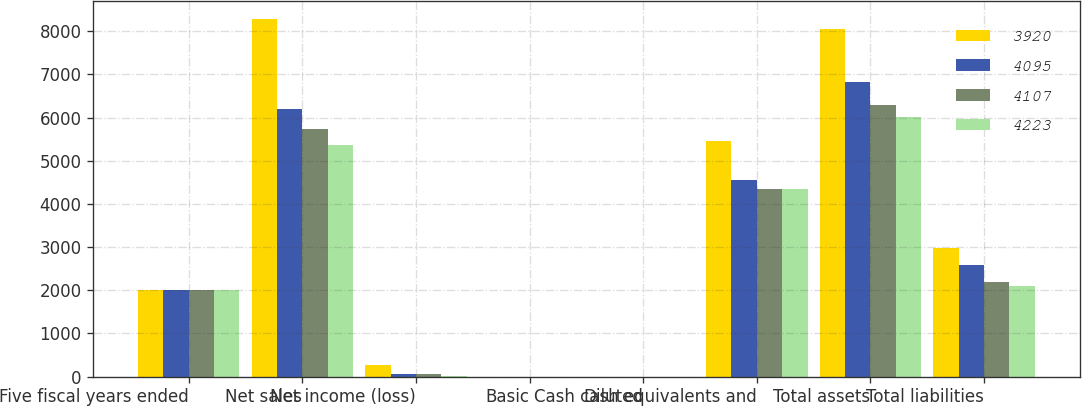<chart> <loc_0><loc_0><loc_500><loc_500><stacked_bar_chart><ecel><fcel>Five fiscal years ended<fcel>Net sales<fcel>Net income (loss)<fcel>Basic<fcel>Diluted<fcel>Cash cash equivalents and<fcel>Total assets<fcel>Total liabilities<nl><fcel>3920<fcel>2004<fcel>8279<fcel>276<fcel>0.74<fcel>0.71<fcel>5464<fcel>8050<fcel>2974<nl><fcel>4095<fcel>2003<fcel>6207<fcel>69<fcel>0.19<fcel>0.19<fcel>4566<fcel>6815<fcel>2592<nl><fcel>4107<fcel>2002<fcel>5742<fcel>65<fcel>0.18<fcel>0.18<fcel>4337<fcel>6298<fcel>2203<nl><fcel>4223<fcel>2001<fcel>5363<fcel>25<fcel>0.07<fcel>0.07<fcel>4336<fcel>6021<fcel>2101<nl></chart> 